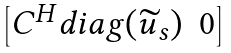Convert formula to latex. <formula><loc_0><loc_0><loc_500><loc_500>\begin{bmatrix} C ^ { H } d i a g ( \widetilde { u } _ { s } ) & 0 \end{bmatrix}</formula> 